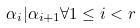Convert formula to latex. <formula><loc_0><loc_0><loc_500><loc_500>\alpha _ { i } | \alpha _ { i + 1 } \forall 1 \leq i < r</formula> 